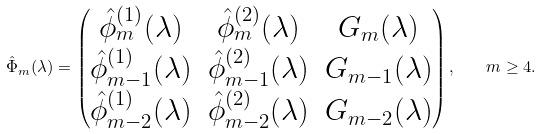Convert formula to latex. <formula><loc_0><loc_0><loc_500><loc_500>\hat { \Phi } _ { m } ( \lambda ) = \begin{pmatrix} \hat { \phi } _ { m } ^ { ( 1 ) } ( \lambda ) & \hat { \phi } _ { m } ^ { ( 2 ) } ( \lambda ) & G _ { m } ( \lambda ) \\ \hat { \phi } _ { m - 1 } ^ { ( 1 ) } ( \lambda ) & \hat { \phi } _ { m - 1 } ^ { ( 2 ) } ( \lambda ) & G _ { m - 1 } ( \lambda ) \\ \hat { \phi } _ { m - 2 } ^ { ( 1 ) } ( \lambda ) & \hat { \phi } _ { m - 2 } ^ { ( 2 ) } ( \lambda ) & G _ { m - 2 } ( \lambda ) \end{pmatrix} , \quad m \geq 4 .</formula> 